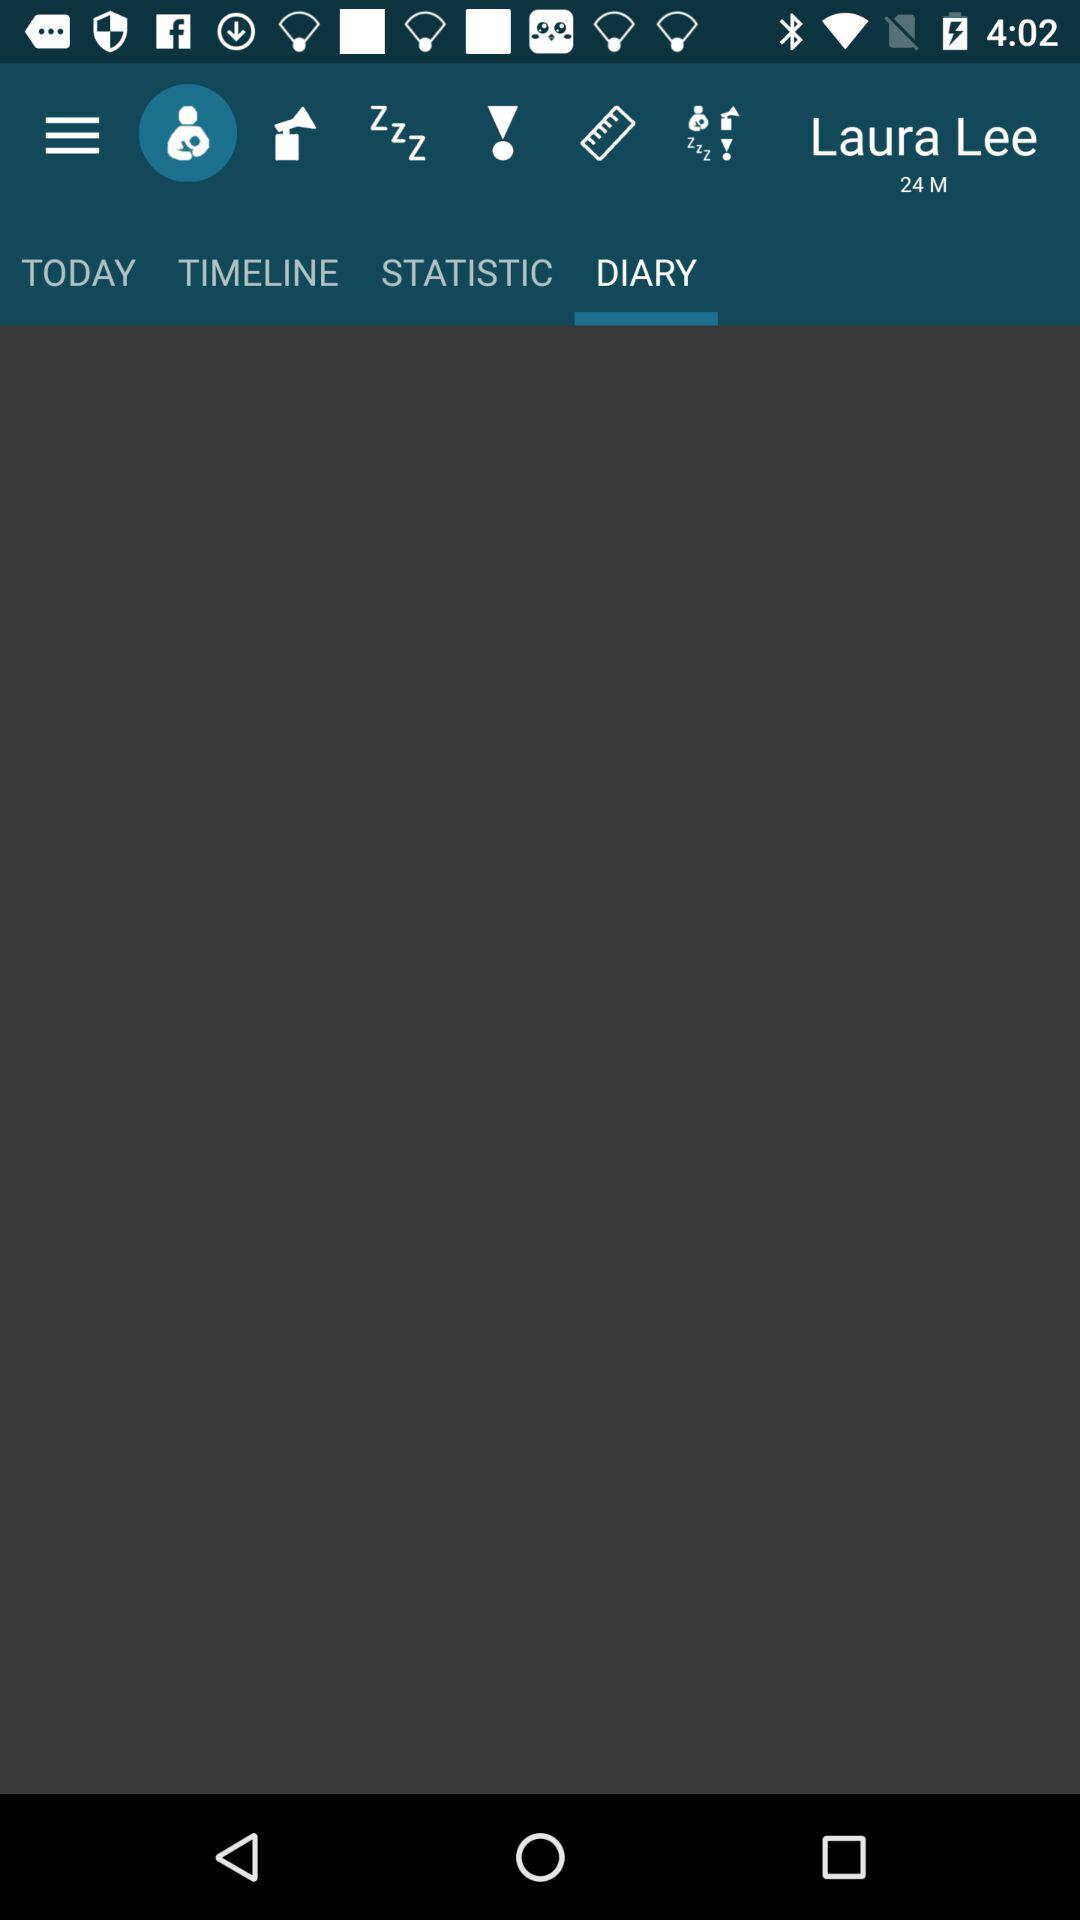What is the age of the user? The user is 24 years old. 